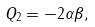<formula> <loc_0><loc_0><loc_500><loc_500>Q _ { 2 } = - 2 \alpha \beta ,</formula> 